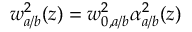<formula> <loc_0><loc_0><loc_500><loc_500>w _ { a / b } ^ { 2 } ( z ) = w _ { 0 , a / b } ^ { 2 } \alpha _ { a / b } ^ { 2 } ( z )</formula> 